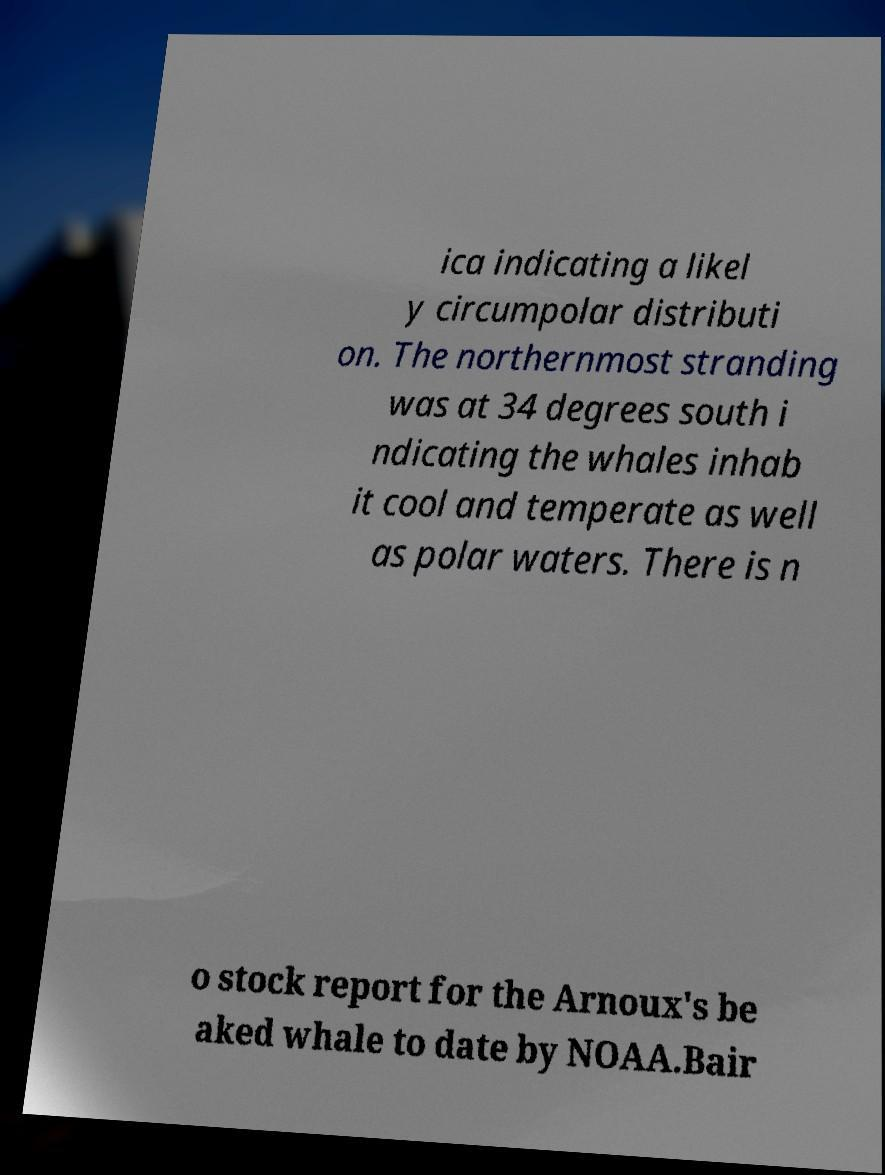Please read and relay the text visible in this image. What does it say? ica indicating a likel y circumpolar distributi on. The northernmost stranding was at 34 degrees south i ndicating the whales inhab it cool and temperate as well as polar waters. There is n o stock report for the Arnoux's be aked whale to date by NOAA.Bair 